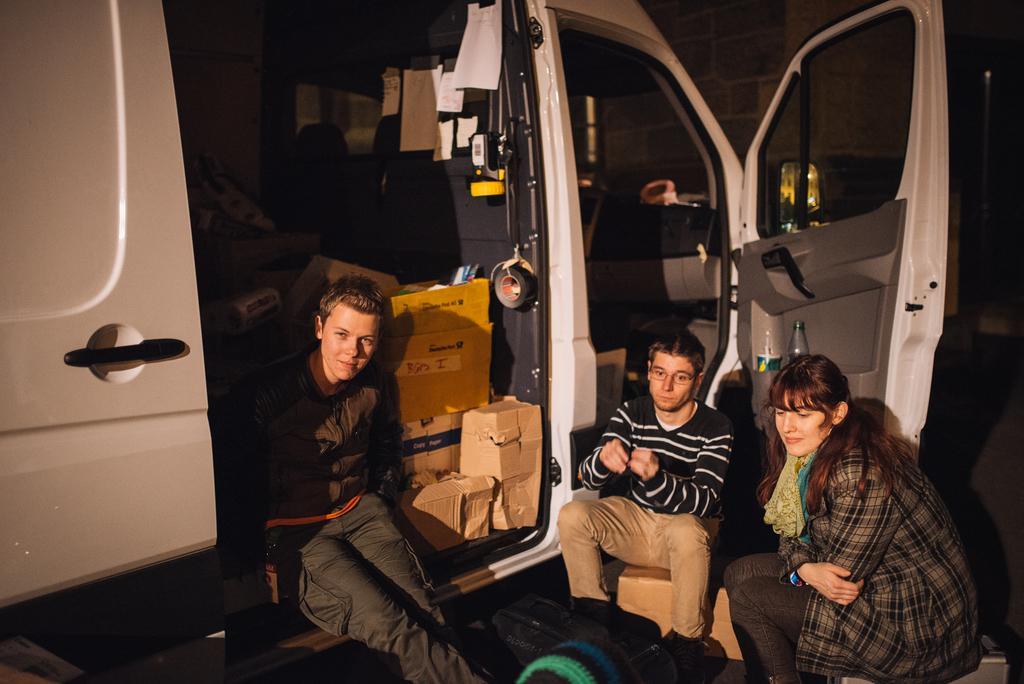Could you give a brief overview of what you see in this image? In this image I can see three people with different color dresses. These people are to the side of the vehicle. The vehicle is in white color. And I can see some cardboard boxes and papers inside the vehicle. 